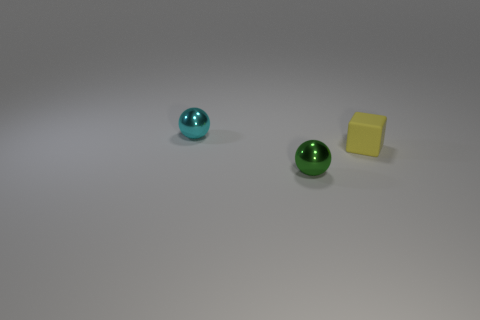Add 3 big red metallic spheres. How many objects exist? 6 Subtract all cubes. How many objects are left? 2 Subtract all large blue metal things. Subtract all small spheres. How many objects are left? 1 Add 3 small cyan things. How many small cyan things are left? 4 Add 1 large purple metal objects. How many large purple metal objects exist? 1 Subtract 0 brown balls. How many objects are left? 3 